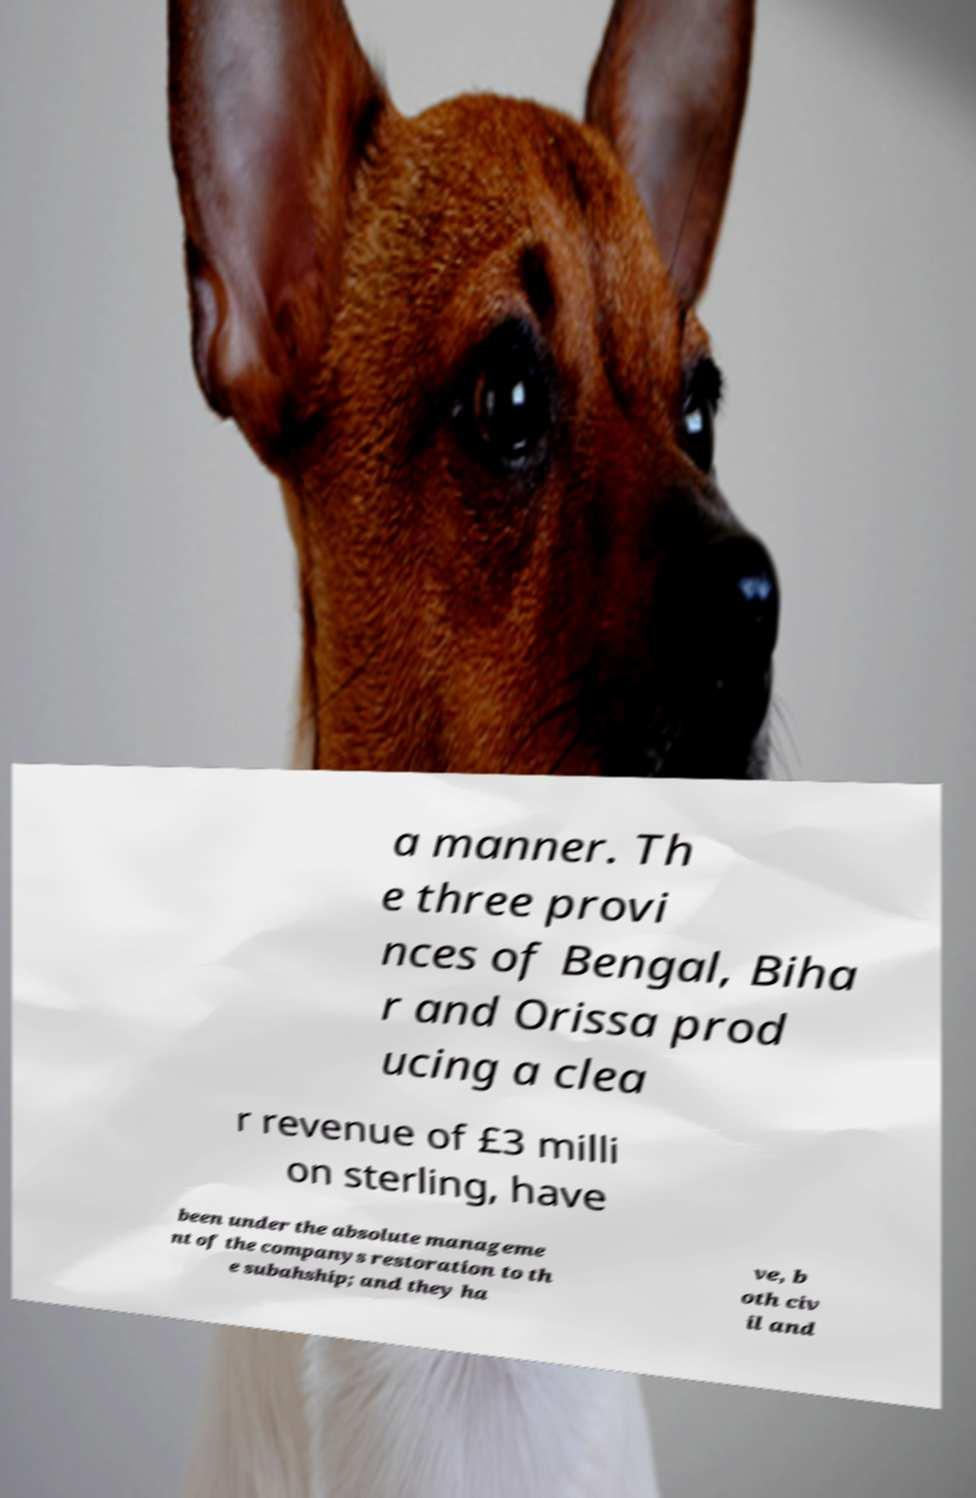Please identify and transcribe the text found in this image. a manner. Th e three provi nces of Bengal, Biha r and Orissa prod ucing a clea r revenue of £3 milli on sterling, have been under the absolute manageme nt of the companys restoration to th e subahship; and they ha ve, b oth civ il and 